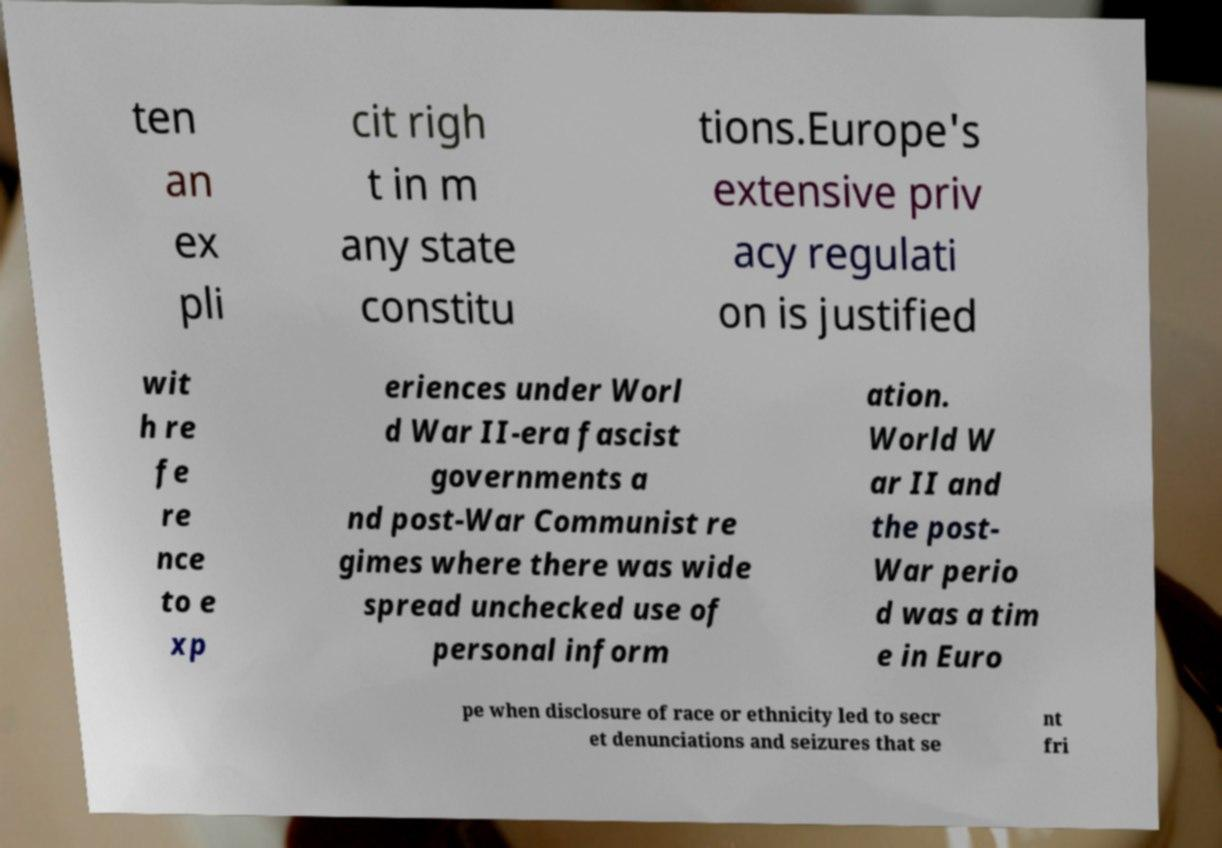For documentation purposes, I need the text within this image transcribed. Could you provide that? ten an ex pli cit righ t in m any state constitu tions.Europe's extensive priv acy regulati on is justified wit h re fe re nce to e xp eriences under Worl d War II-era fascist governments a nd post-War Communist re gimes where there was wide spread unchecked use of personal inform ation. World W ar II and the post- War perio d was a tim e in Euro pe when disclosure of race or ethnicity led to secr et denunciations and seizures that se nt fri 